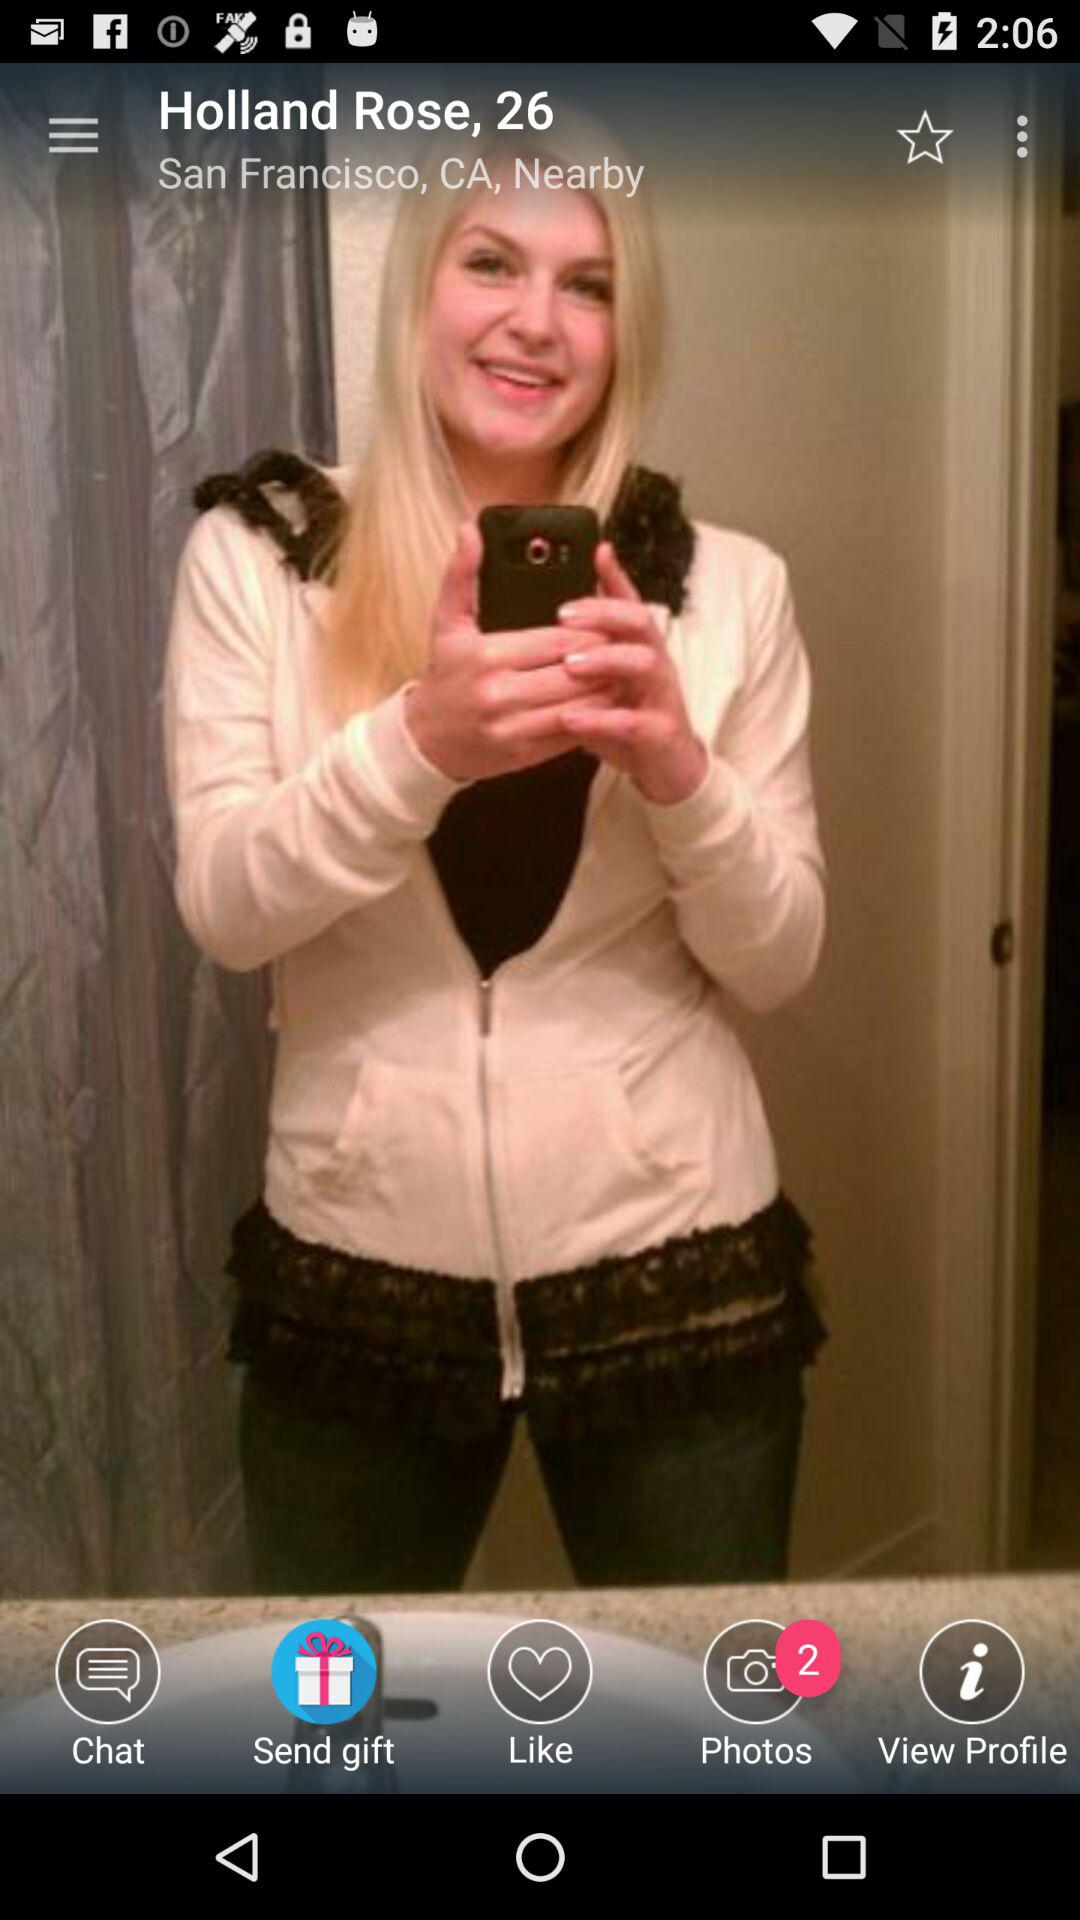What is the user name? The user name is Holland Rose. 